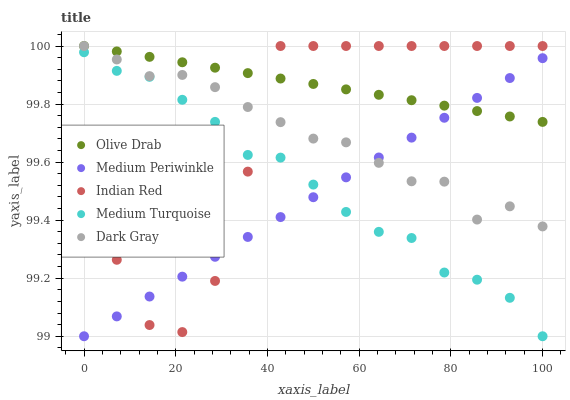Does Medium Periwinkle have the minimum area under the curve?
Answer yes or no. Yes. Does Olive Drab have the maximum area under the curve?
Answer yes or no. Yes. Does Medium Turquoise have the minimum area under the curve?
Answer yes or no. No. Does Medium Turquoise have the maximum area under the curve?
Answer yes or no. No. Is Olive Drab the smoothest?
Answer yes or no. Yes. Is Indian Red the roughest?
Answer yes or no. Yes. Is Medium Turquoise the smoothest?
Answer yes or no. No. Is Medium Turquoise the roughest?
Answer yes or no. No. Does Medium Turquoise have the lowest value?
Answer yes or no. Yes. Does Indian Red have the lowest value?
Answer yes or no. No. Does Olive Drab have the highest value?
Answer yes or no. Yes. Does Medium Turquoise have the highest value?
Answer yes or no. No. Is Medium Turquoise less than Olive Drab?
Answer yes or no. Yes. Is Olive Drab greater than Medium Turquoise?
Answer yes or no. Yes. Does Dark Gray intersect Medium Periwinkle?
Answer yes or no. Yes. Is Dark Gray less than Medium Periwinkle?
Answer yes or no. No. Is Dark Gray greater than Medium Periwinkle?
Answer yes or no. No. Does Medium Turquoise intersect Olive Drab?
Answer yes or no. No. 